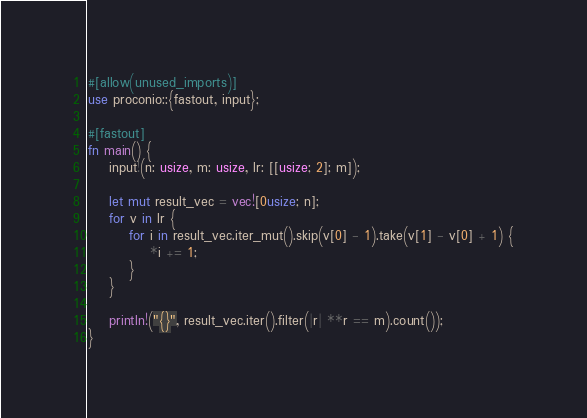<code> <loc_0><loc_0><loc_500><loc_500><_Rust_>#[allow(unused_imports)]
use proconio::{fastout, input};

#[fastout]
fn main() {
    input!(n: usize, m: usize, lr: [[usize; 2]; m]);

    let mut result_vec = vec![0usize; n];
    for v in lr {
        for i in result_vec.iter_mut().skip(v[0] - 1).take(v[1] - v[0] + 1) {
            *i += 1;
        }
    }

    println!("{}", result_vec.iter().filter(|r| **r == m).count());
}
</code> 